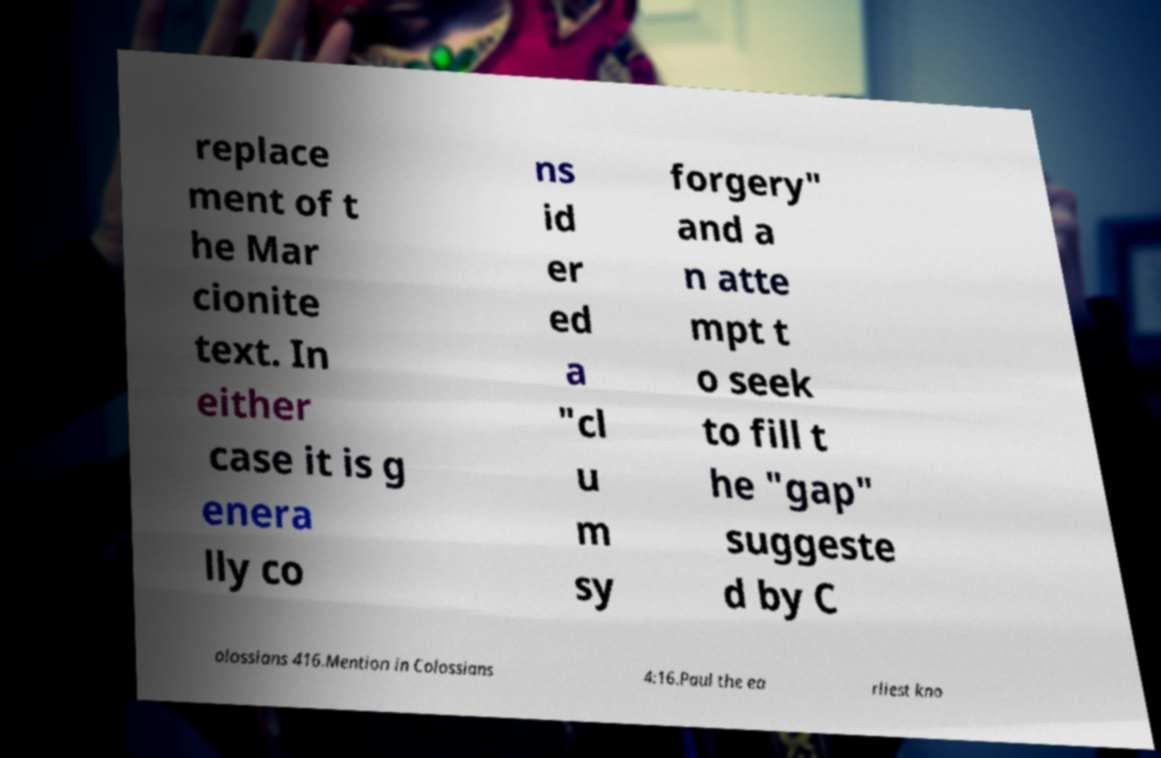Can you read and provide the text displayed in the image?This photo seems to have some interesting text. Can you extract and type it out for me? replace ment of t he Mar cionite text. In either case it is g enera lly co ns id er ed a "cl u m sy forgery" and a n atte mpt t o seek to fill t he "gap" suggeste d by C olossians 416.Mention in Colossians 4:16.Paul the ea rliest kno 